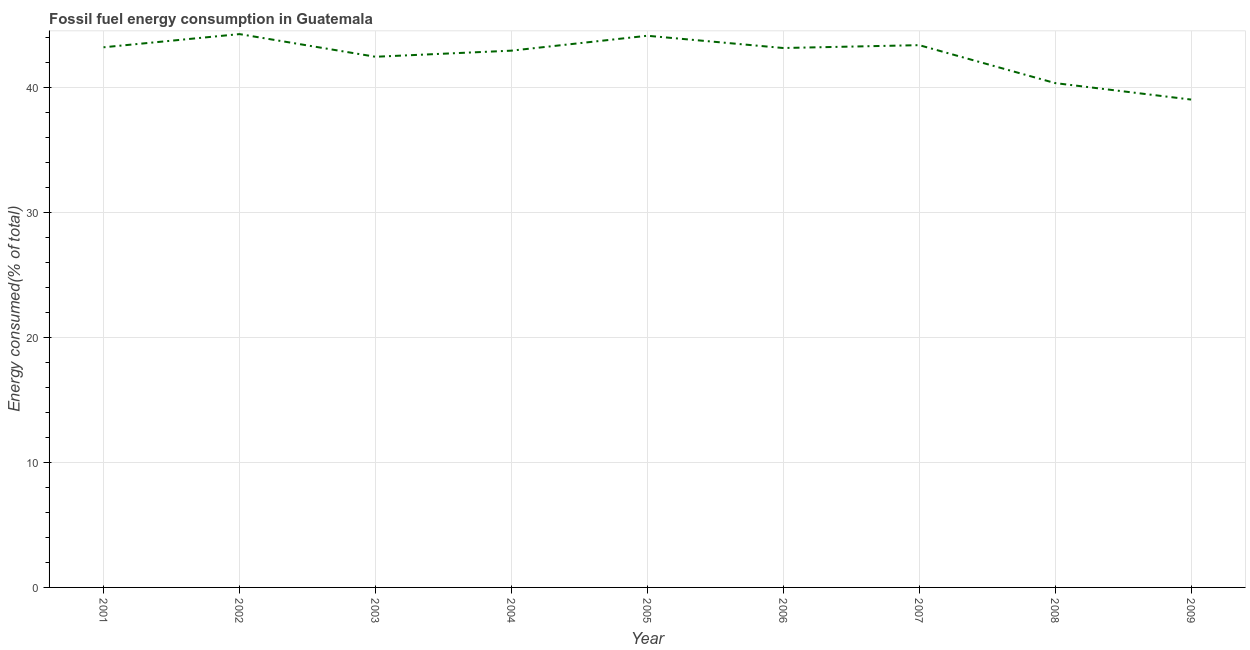What is the fossil fuel energy consumption in 2008?
Offer a very short reply. 40.38. Across all years, what is the maximum fossil fuel energy consumption?
Your answer should be compact. 44.3. Across all years, what is the minimum fossil fuel energy consumption?
Make the answer very short. 39.06. What is the sum of the fossil fuel energy consumption?
Keep it short and to the point. 383.22. What is the difference between the fossil fuel energy consumption in 2003 and 2007?
Your answer should be very brief. -0.93. What is the average fossil fuel energy consumption per year?
Provide a succinct answer. 42.58. What is the median fossil fuel energy consumption?
Your answer should be very brief. 43.19. In how many years, is the fossil fuel energy consumption greater than 28 %?
Provide a short and direct response. 9. Do a majority of the years between 2001 and 2006 (inclusive) have fossil fuel energy consumption greater than 12 %?
Ensure brevity in your answer.  Yes. What is the ratio of the fossil fuel energy consumption in 2002 to that in 2008?
Give a very brief answer. 1.1. Is the fossil fuel energy consumption in 2003 less than that in 2007?
Your response must be concise. Yes. Is the difference between the fossil fuel energy consumption in 2004 and 2008 greater than the difference between any two years?
Make the answer very short. No. What is the difference between the highest and the second highest fossil fuel energy consumption?
Ensure brevity in your answer.  0.13. What is the difference between the highest and the lowest fossil fuel energy consumption?
Offer a terse response. 5.24. Does the fossil fuel energy consumption monotonically increase over the years?
Your answer should be compact. No. What is the difference between two consecutive major ticks on the Y-axis?
Your answer should be very brief. 10. Are the values on the major ticks of Y-axis written in scientific E-notation?
Provide a succinct answer. No. Does the graph contain any zero values?
Your answer should be very brief. No. Does the graph contain grids?
Keep it short and to the point. Yes. What is the title of the graph?
Make the answer very short. Fossil fuel energy consumption in Guatemala. What is the label or title of the Y-axis?
Give a very brief answer. Energy consumed(% of total). What is the Energy consumed(% of total) of 2001?
Your answer should be compact. 43.24. What is the Energy consumed(% of total) in 2002?
Your answer should be compact. 44.3. What is the Energy consumed(% of total) in 2003?
Make the answer very short. 42.49. What is the Energy consumed(% of total) of 2004?
Make the answer very short. 42.98. What is the Energy consumed(% of total) in 2005?
Provide a short and direct response. 44.17. What is the Energy consumed(% of total) of 2006?
Provide a succinct answer. 43.19. What is the Energy consumed(% of total) in 2007?
Your answer should be very brief. 43.42. What is the Energy consumed(% of total) of 2008?
Offer a terse response. 40.38. What is the Energy consumed(% of total) of 2009?
Give a very brief answer. 39.06. What is the difference between the Energy consumed(% of total) in 2001 and 2002?
Your answer should be compact. -1.06. What is the difference between the Energy consumed(% of total) in 2001 and 2003?
Provide a succinct answer. 0.76. What is the difference between the Energy consumed(% of total) in 2001 and 2004?
Make the answer very short. 0.27. What is the difference between the Energy consumed(% of total) in 2001 and 2005?
Your response must be concise. -0.92. What is the difference between the Energy consumed(% of total) in 2001 and 2006?
Provide a succinct answer. 0.06. What is the difference between the Energy consumed(% of total) in 2001 and 2007?
Offer a terse response. -0.17. What is the difference between the Energy consumed(% of total) in 2001 and 2008?
Make the answer very short. 2.87. What is the difference between the Energy consumed(% of total) in 2001 and 2009?
Your answer should be compact. 4.19. What is the difference between the Energy consumed(% of total) in 2002 and 2003?
Provide a succinct answer. 1.81. What is the difference between the Energy consumed(% of total) in 2002 and 2004?
Ensure brevity in your answer.  1.33. What is the difference between the Energy consumed(% of total) in 2002 and 2005?
Your response must be concise. 0.13. What is the difference between the Energy consumed(% of total) in 2002 and 2006?
Your answer should be very brief. 1.11. What is the difference between the Energy consumed(% of total) in 2002 and 2007?
Your answer should be very brief. 0.89. What is the difference between the Energy consumed(% of total) in 2002 and 2008?
Make the answer very short. 3.92. What is the difference between the Energy consumed(% of total) in 2002 and 2009?
Ensure brevity in your answer.  5.24. What is the difference between the Energy consumed(% of total) in 2003 and 2004?
Your response must be concise. -0.49. What is the difference between the Energy consumed(% of total) in 2003 and 2005?
Make the answer very short. -1.68. What is the difference between the Energy consumed(% of total) in 2003 and 2006?
Give a very brief answer. -0.7. What is the difference between the Energy consumed(% of total) in 2003 and 2007?
Your answer should be compact. -0.93. What is the difference between the Energy consumed(% of total) in 2003 and 2008?
Your response must be concise. 2.11. What is the difference between the Energy consumed(% of total) in 2003 and 2009?
Provide a short and direct response. 3.43. What is the difference between the Energy consumed(% of total) in 2004 and 2005?
Ensure brevity in your answer.  -1.19. What is the difference between the Energy consumed(% of total) in 2004 and 2006?
Provide a short and direct response. -0.21. What is the difference between the Energy consumed(% of total) in 2004 and 2007?
Provide a succinct answer. -0.44. What is the difference between the Energy consumed(% of total) in 2004 and 2008?
Offer a very short reply. 2.6. What is the difference between the Energy consumed(% of total) in 2004 and 2009?
Keep it short and to the point. 3.92. What is the difference between the Energy consumed(% of total) in 2005 and 2006?
Offer a terse response. 0.98. What is the difference between the Energy consumed(% of total) in 2005 and 2007?
Ensure brevity in your answer.  0.75. What is the difference between the Energy consumed(% of total) in 2005 and 2008?
Offer a very short reply. 3.79. What is the difference between the Energy consumed(% of total) in 2005 and 2009?
Provide a short and direct response. 5.11. What is the difference between the Energy consumed(% of total) in 2006 and 2007?
Offer a very short reply. -0.23. What is the difference between the Energy consumed(% of total) in 2006 and 2008?
Give a very brief answer. 2.81. What is the difference between the Energy consumed(% of total) in 2006 and 2009?
Offer a very short reply. 4.13. What is the difference between the Energy consumed(% of total) in 2007 and 2008?
Ensure brevity in your answer.  3.04. What is the difference between the Energy consumed(% of total) in 2007 and 2009?
Your answer should be very brief. 4.36. What is the difference between the Energy consumed(% of total) in 2008 and 2009?
Your response must be concise. 1.32. What is the ratio of the Energy consumed(% of total) in 2001 to that in 2002?
Make the answer very short. 0.98. What is the ratio of the Energy consumed(% of total) in 2001 to that in 2004?
Give a very brief answer. 1.01. What is the ratio of the Energy consumed(% of total) in 2001 to that in 2007?
Your response must be concise. 1. What is the ratio of the Energy consumed(% of total) in 2001 to that in 2008?
Ensure brevity in your answer.  1.07. What is the ratio of the Energy consumed(% of total) in 2001 to that in 2009?
Give a very brief answer. 1.11. What is the ratio of the Energy consumed(% of total) in 2002 to that in 2003?
Ensure brevity in your answer.  1.04. What is the ratio of the Energy consumed(% of total) in 2002 to that in 2004?
Offer a terse response. 1.03. What is the ratio of the Energy consumed(% of total) in 2002 to that in 2005?
Provide a succinct answer. 1. What is the ratio of the Energy consumed(% of total) in 2002 to that in 2006?
Ensure brevity in your answer.  1.03. What is the ratio of the Energy consumed(% of total) in 2002 to that in 2007?
Your answer should be compact. 1.02. What is the ratio of the Energy consumed(% of total) in 2002 to that in 2008?
Your answer should be compact. 1.1. What is the ratio of the Energy consumed(% of total) in 2002 to that in 2009?
Offer a very short reply. 1.13. What is the ratio of the Energy consumed(% of total) in 2003 to that in 2004?
Make the answer very short. 0.99. What is the ratio of the Energy consumed(% of total) in 2003 to that in 2005?
Make the answer very short. 0.96. What is the ratio of the Energy consumed(% of total) in 2003 to that in 2006?
Ensure brevity in your answer.  0.98. What is the ratio of the Energy consumed(% of total) in 2003 to that in 2008?
Give a very brief answer. 1.05. What is the ratio of the Energy consumed(% of total) in 2003 to that in 2009?
Offer a very short reply. 1.09. What is the ratio of the Energy consumed(% of total) in 2004 to that in 2007?
Ensure brevity in your answer.  0.99. What is the ratio of the Energy consumed(% of total) in 2004 to that in 2008?
Ensure brevity in your answer.  1.06. What is the ratio of the Energy consumed(% of total) in 2005 to that in 2006?
Provide a succinct answer. 1.02. What is the ratio of the Energy consumed(% of total) in 2005 to that in 2008?
Your answer should be compact. 1.09. What is the ratio of the Energy consumed(% of total) in 2005 to that in 2009?
Your answer should be compact. 1.13. What is the ratio of the Energy consumed(% of total) in 2006 to that in 2008?
Give a very brief answer. 1.07. What is the ratio of the Energy consumed(% of total) in 2006 to that in 2009?
Your response must be concise. 1.11. What is the ratio of the Energy consumed(% of total) in 2007 to that in 2008?
Your answer should be very brief. 1.07. What is the ratio of the Energy consumed(% of total) in 2007 to that in 2009?
Provide a succinct answer. 1.11. What is the ratio of the Energy consumed(% of total) in 2008 to that in 2009?
Provide a short and direct response. 1.03. 